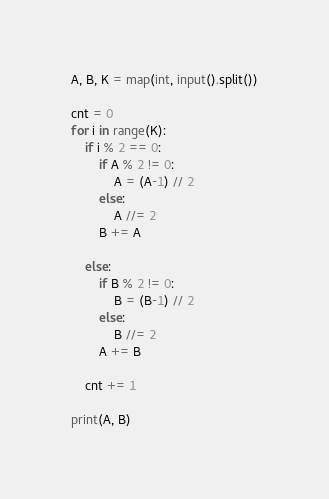<code> <loc_0><loc_0><loc_500><loc_500><_Python_>A, B, K = map(int, input().split())

cnt = 0
for i in range(K):
    if i % 2 == 0:
        if A % 2 != 0:
            A = (A-1) // 2
        else:
            A //= 2
        B += A

    else:
        if B % 2 != 0:
            B = (B-1) // 2
        else:
            B //= 2
        A += B

    cnt += 1

print(A, B)
</code> 